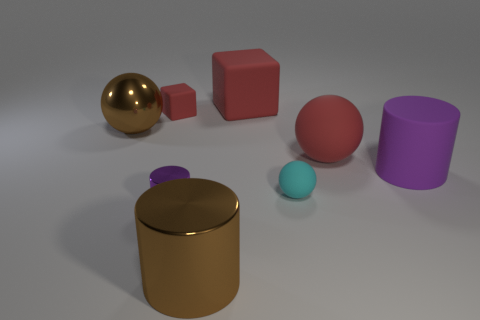How many objects are large cylinders right of the large red block or blocks in front of the big red rubber block?
Make the answer very short. 2. The tiny cylinder has what color?
Make the answer very short. Purple. What number of small balls are the same material as the large red ball?
Provide a succinct answer. 1. Are there more tiny purple metallic things than blue matte cylinders?
Offer a terse response. Yes. There is a big ball that is to the right of the small red rubber block; what number of big red spheres are behind it?
Keep it short and to the point. 0. How many objects are rubber objects behind the big matte ball or big rubber things?
Your answer should be compact. 4. Are there any other tiny purple metal objects that have the same shape as the small metal thing?
Ensure brevity in your answer.  No. What is the shape of the brown thing that is to the left of the large shiny object that is on the right side of the purple metal cylinder?
Make the answer very short. Sphere. How many cylinders are tiny things or purple things?
Offer a terse response. 2. What material is the cylinder that is the same color as the metal ball?
Give a very brief answer. Metal. 